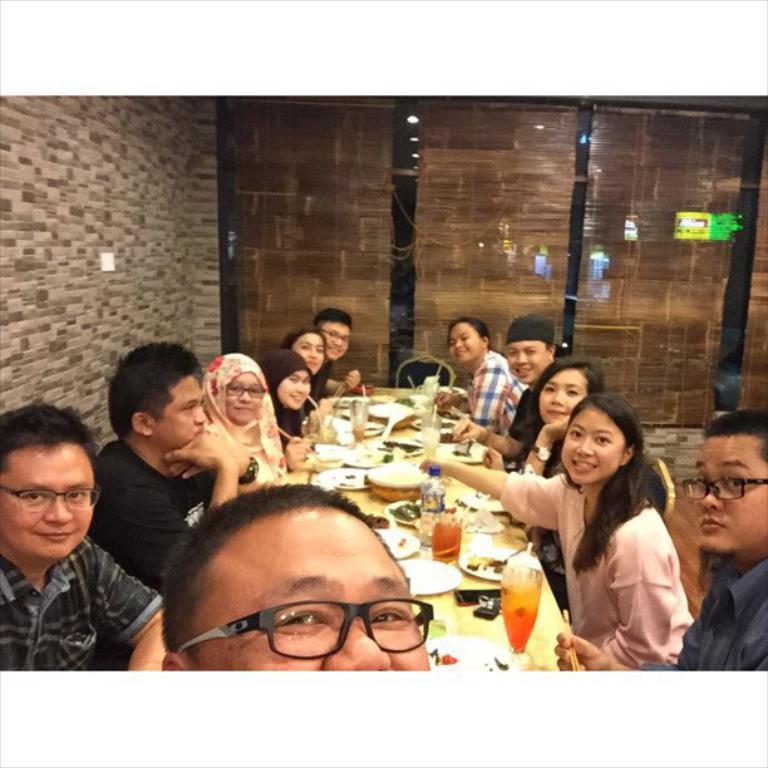Describe this image in one or two sentences. In this image we can see a group of people sitting on the chairs beside a table containing some glasses, bottles, bowls and some plates on it. On the backside we can see an empty chair and a wall. 